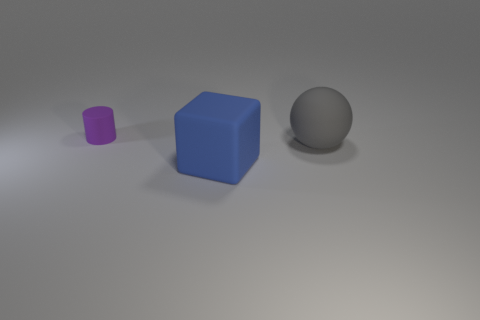Add 1 cubes. How many cubes are left? 2 Add 2 small rubber cylinders. How many small rubber cylinders exist? 3 Add 3 purple matte objects. How many objects exist? 6 Subtract 0 purple spheres. How many objects are left? 3 Subtract all blocks. How many objects are left? 2 Subtract 1 blocks. How many blocks are left? 0 Subtract all red cylinders. Subtract all cyan blocks. How many cylinders are left? 1 Subtract all yellow blocks. How many green cylinders are left? 0 Subtract all small green objects. Subtract all big matte spheres. How many objects are left? 2 